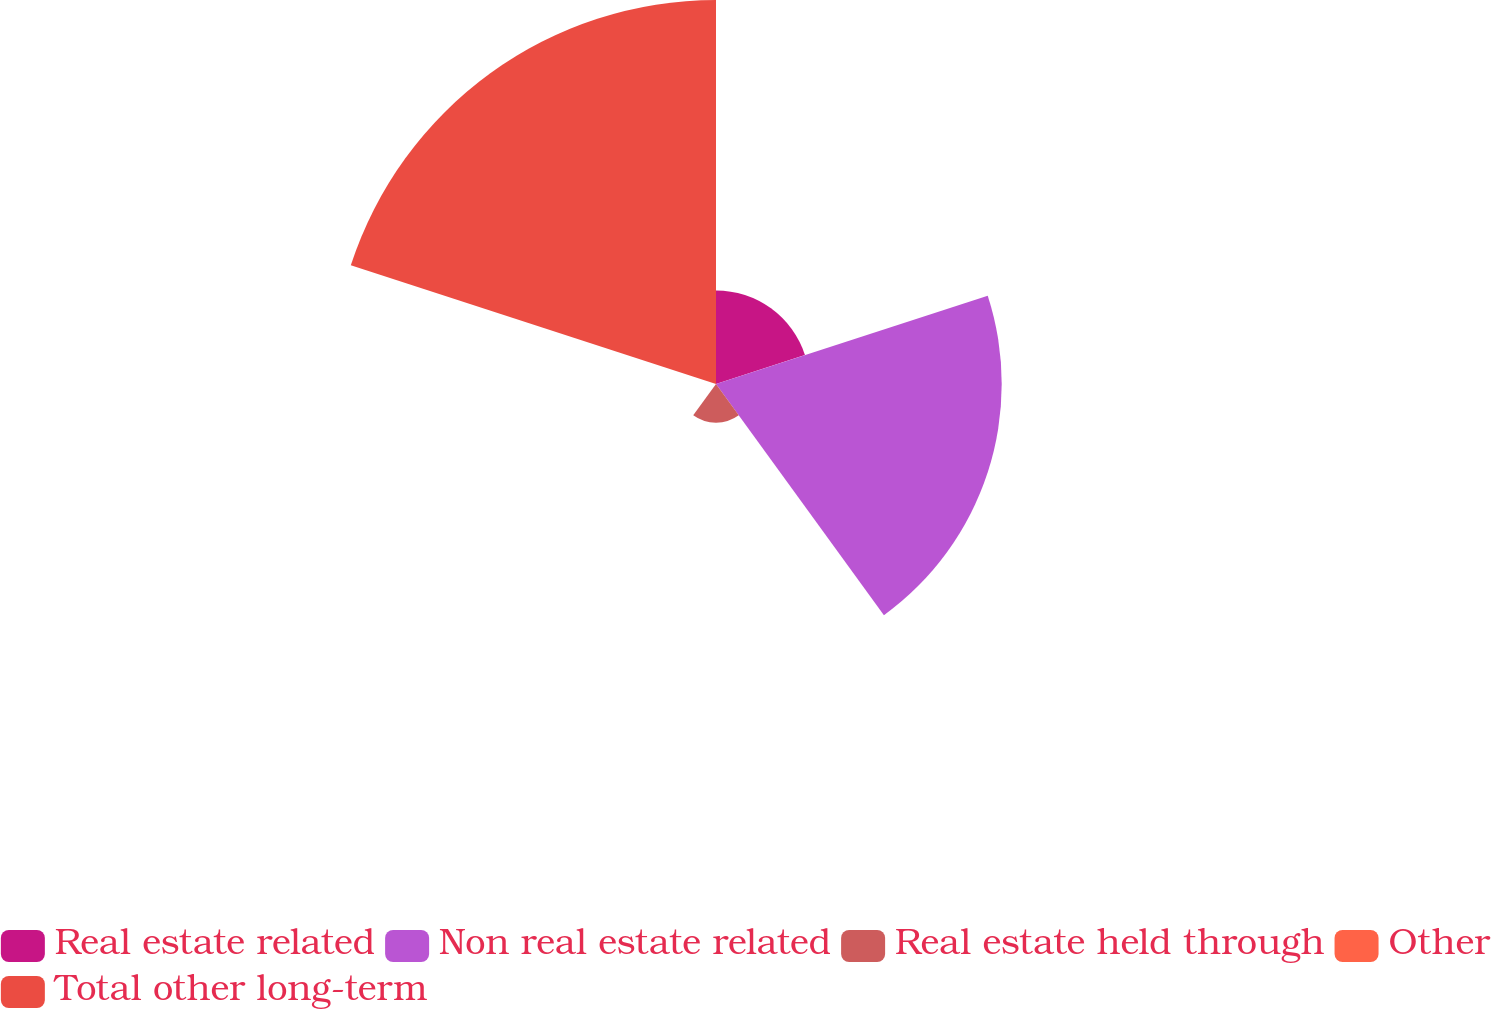Convert chart to OTSL. <chart><loc_0><loc_0><loc_500><loc_500><pie_chart><fcel>Real estate related<fcel>Non real estate related<fcel>Real estate held through<fcel>Other<fcel>Total other long-term<nl><fcel>11.66%<fcel>35.61%<fcel>4.83%<fcel>0.05%<fcel>47.86%<nl></chart> 